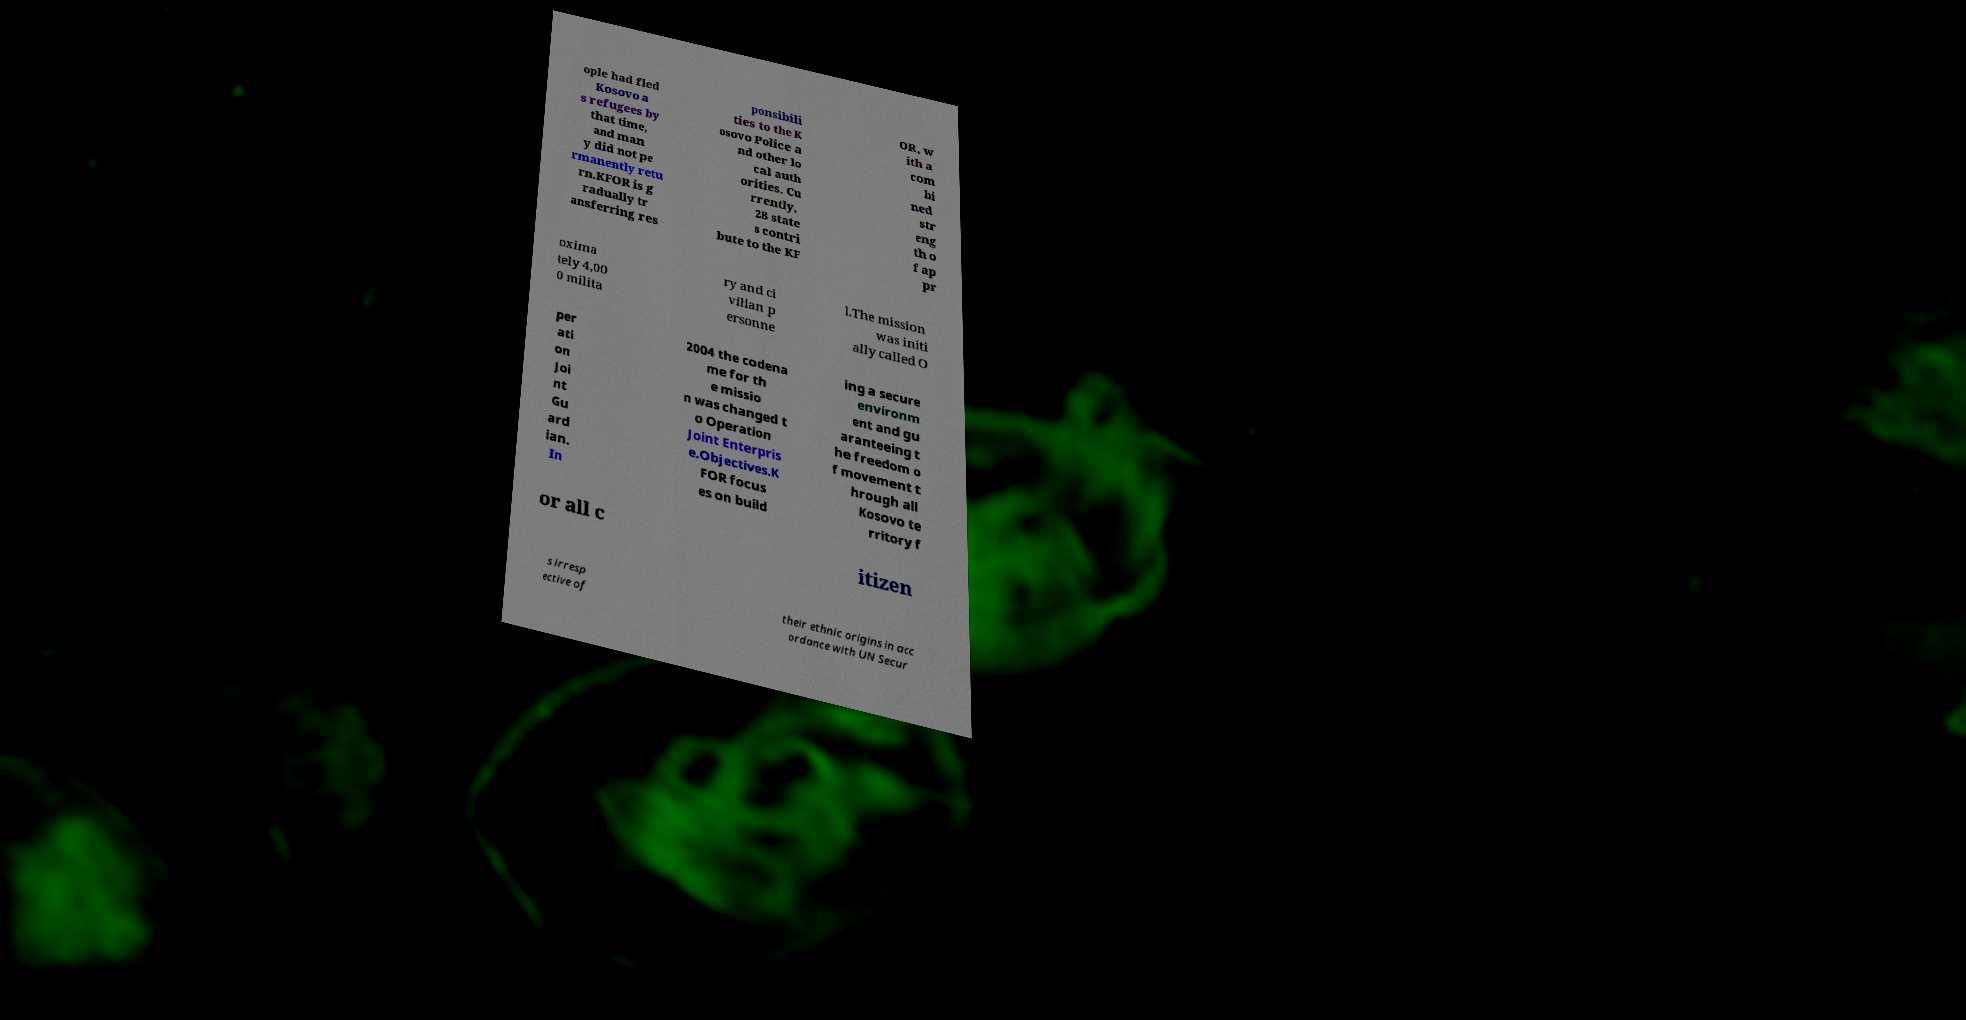What messages or text are displayed in this image? I need them in a readable, typed format. ople had fled Kosovo a s refugees by that time, and man y did not pe rmanently retu rn.KFOR is g radually tr ansferring res ponsibili ties to the K osovo Police a nd other lo cal auth orities. Cu rrently, 28 state s contri bute to the KF OR, w ith a com bi ned str eng th o f ap pr oxima tely 4,00 0 milita ry and ci vilian p ersonne l.The mission was initi ally called O per ati on Joi nt Gu ard ian. In 2004 the codena me for th e missio n was changed t o Operation Joint Enterpris e.Objectives.K FOR focus es on build ing a secure environm ent and gu aranteeing t he freedom o f movement t hrough all Kosovo te rritory f or all c itizen s irresp ective of their ethnic origins in acc ordance with UN Secur 